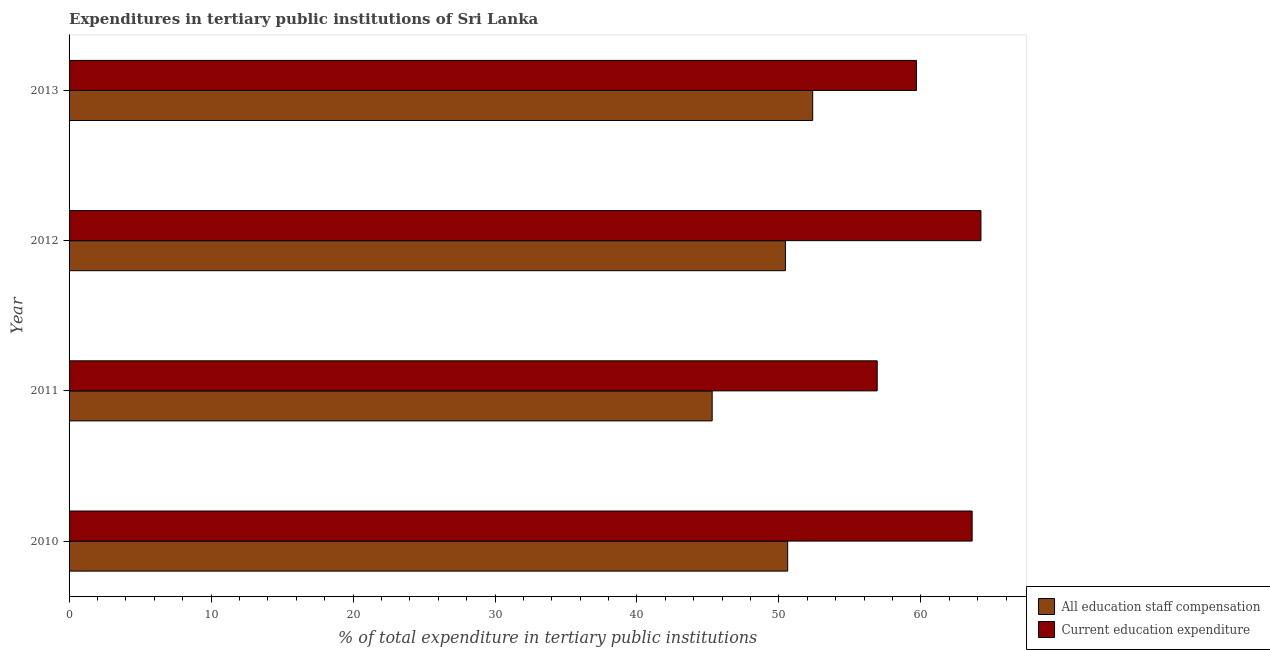Are the number of bars per tick equal to the number of legend labels?
Make the answer very short. Yes. What is the expenditure in staff compensation in 2013?
Keep it short and to the point. 52.38. Across all years, what is the maximum expenditure in education?
Offer a terse response. 64.23. Across all years, what is the minimum expenditure in education?
Offer a very short reply. 56.92. In which year was the expenditure in education maximum?
Offer a terse response. 2012. What is the total expenditure in education in the graph?
Your answer should be compact. 244.44. What is the difference between the expenditure in staff compensation in 2010 and that in 2011?
Give a very brief answer. 5.32. What is the difference between the expenditure in staff compensation in 2011 and the expenditure in education in 2012?
Make the answer very short. -18.93. What is the average expenditure in education per year?
Make the answer very short. 61.11. In the year 2013, what is the difference between the expenditure in education and expenditure in staff compensation?
Provide a succinct answer. 7.31. In how many years, is the expenditure in staff compensation greater than 32 %?
Your response must be concise. 4. What is the ratio of the expenditure in staff compensation in 2012 to that in 2013?
Your response must be concise. 0.96. Is the expenditure in education in 2011 less than that in 2012?
Your response must be concise. Yes. Is the difference between the expenditure in staff compensation in 2010 and 2011 greater than the difference between the expenditure in education in 2010 and 2011?
Your answer should be compact. No. What is the difference between the highest and the second highest expenditure in education?
Keep it short and to the point. 0.62. What is the difference between the highest and the lowest expenditure in education?
Provide a short and direct response. 7.31. Is the sum of the expenditure in education in 2010 and 2012 greater than the maximum expenditure in staff compensation across all years?
Your answer should be compact. Yes. What does the 1st bar from the top in 2010 represents?
Your answer should be compact. Current education expenditure. What does the 2nd bar from the bottom in 2010 represents?
Your answer should be very brief. Current education expenditure. How many years are there in the graph?
Offer a terse response. 4. What is the difference between two consecutive major ticks on the X-axis?
Provide a short and direct response. 10. Does the graph contain any zero values?
Your answer should be very brief. No. Does the graph contain grids?
Your response must be concise. No. Where does the legend appear in the graph?
Offer a terse response. Bottom right. How many legend labels are there?
Keep it short and to the point. 2. What is the title of the graph?
Your response must be concise. Expenditures in tertiary public institutions of Sri Lanka. Does "Age 15+" appear as one of the legend labels in the graph?
Your answer should be very brief. No. What is the label or title of the X-axis?
Keep it short and to the point. % of total expenditure in tertiary public institutions. What is the % of total expenditure in tertiary public institutions of All education staff compensation in 2010?
Give a very brief answer. 50.61. What is the % of total expenditure in tertiary public institutions in Current education expenditure in 2010?
Provide a short and direct response. 63.61. What is the % of total expenditure in tertiary public institutions in All education staff compensation in 2011?
Make the answer very short. 45.3. What is the % of total expenditure in tertiary public institutions in Current education expenditure in 2011?
Ensure brevity in your answer.  56.92. What is the % of total expenditure in tertiary public institutions in All education staff compensation in 2012?
Your answer should be very brief. 50.45. What is the % of total expenditure in tertiary public institutions of Current education expenditure in 2012?
Offer a terse response. 64.23. What is the % of total expenditure in tertiary public institutions in All education staff compensation in 2013?
Ensure brevity in your answer.  52.38. What is the % of total expenditure in tertiary public institutions in Current education expenditure in 2013?
Your answer should be very brief. 59.68. Across all years, what is the maximum % of total expenditure in tertiary public institutions of All education staff compensation?
Your answer should be very brief. 52.38. Across all years, what is the maximum % of total expenditure in tertiary public institutions of Current education expenditure?
Provide a succinct answer. 64.23. Across all years, what is the minimum % of total expenditure in tertiary public institutions in All education staff compensation?
Make the answer very short. 45.3. Across all years, what is the minimum % of total expenditure in tertiary public institutions in Current education expenditure?
Provide a short and direct response. 56.92. What is the total % of total expenditure in tertiary public institutions of All education staff compensation in the graph?
Keep it short and to the point. 198.74. What is the total % of total expenditure in tertiary public institutions in Current education expenditure in the graph?
Give a very brief answer. 244.44. What is the difference between the % of total expenditure in tertiary public institutions in All education staff compensation in 2010 and that in 2011?
Your response must be concise. 5.32. What is the difference between the % of total expenditure in tertiary public institutions of Current education expenditure in 2010 and that in 2011?
Make the answer very short. 6.69. What is the difference between the % of total expenditure in tertiary public institutions in All education staff compensation in 2010 and that in 2012?
Ensure brevity in your answer.  0.16. What is the difference between the % of total expenditure in tertiary public institutions in Current education expenditure in 2010 and that in 2012?
Make the answer very short. -0.62. What is the difference between the % of total expenditure in tertiary public institutions of All education staff compensation in 2010 and that in 2013?
Your response must be concise. -1.76. What is the difference between the % of total expenditure in tertiary public institutions of Current education expenditure in 2010 and that in 2013?
Offer a terse response. 3.92. What is the difference between the % of total expenditure in tertiary public institutions of All education staff compensation in 2011 and that in 2012?
Make the answer very short. -5.16. What is the difference between the % of total expenditure in tertiary public institutions of Current education expenditure in 2011 and that in 2012?
Offer a very short reply. -7.31. What is the difference between the % of total expenditure in tertiary public institutions in All education staff compensation in 2011 and that in 2013?
Your answer should be compact. -7.08. What is the difference between the % of total expenditure in tertiary public institutions in Current education expenditure in 2011 and that in 2013?
Offer a terse response. -2.76. What is the difference between the % of total expenditure in tertiary public institutions in All education staff compensation in 2012 and that in 2013?
Provide a short and direct response. -1.92. What is the difference between the % of total expenditure in tertiary public institutions in Current education expenditure in 2012 and that in 2013?
Offer a terse response. 4.54. What is the difference between the % of total expenditure in tertiary public institutions in All education staff compensation in 2010 and the % of total expenditure in tertiary public institutions in Current education expenditure in 2011?
Ensure brevity in your answer.  -6.31. What is the difference between the % of total expenditure in tertiary public institutions of All education staff compensation in 2010 and the % of total expenditure in tertiary public institutions of Current education expenditure in 2012?
Your answer should be very brief. -13.61. What is the difference between the % of total expenditure in tertiary public institutions in All education staff compensation in 2010 and the % of total expenditure in tertiary public institutions in Current education expenditure in 2013?
Offer a terse response. -9.07. What is the difference between the % of total expenditure in tertiary public institutions of All education staff compensation in 2011 and the % of total expenditure in tertiary public institutions of Current education expenditure in 2012?
Provide a short and direct response. -18.93. What is the difference between the % of total expenditure in tertiary public institutions of All education staff compensation in 2011 and the % of total expenditure in tertiary public institutions of Current education expenditure in 2013?
Offer a terse response. -14.39. What is the difference between the % of total expenditure in tertiary public institutions in All education staff compensation in 2012 and the % of total expenditure in tertiary public institutions in Current education expenditure in 2013?
Your response must be concise. -9.23. What is the average % of total expenditure in tertiary public institutions of All education staff compensation per year?
Provide a short and direct response. 49.69. What is the average % of total expenditure in tertiary public institutions of Current education expenditure per year?
Provide a short and direct response. 61.11. In the year 2010, what is the difference between the % of total expenditure in tertiary public institutions in All education staff compensation and % of total expenditure in tertiary public institutions in Current education expenditure?
Offer a terse response. -12.99. In the year 2011, what is the difference between the % of total expenditure in tertiary public institutions in All education staff compensation and % of total expenditure in tertiary public institutions in Current education expenditure?
Give a very brief answer. -11.62. In the year 2012, what is the difference between the % of total expenditure in tertiary public institutions in All education staff compensation and % of total expenditure in tertiary public institutions in Current education expenditure?
Your response must be concise. -13.77. In the year 2013, what is the difference between the % of total expenditure in tertiary public institutions of All education staff compensation and % of total expenditure in tertiary public institutions of Current education expenditure?
Ensure brevity in your answer.  -7.31. What is the ratio of the % of total expenditure in tertiary public institutions in All education staff compensation in 2010 to that in 2011?
Ensure brevity in your answer.  1.12. What is the ratio of the % of total expenditure in tertiary public institutions in Current education expenditure in 2010 to that in 2011?
Keep it short and to the point. 1.12. What is the ratio of the % of total expenditure in tertiary public institutions of All education staff compensation in 2010 to that in 2012?
Offer a terse response. 1. What is the ratio of the % of total expenditure in tertiary public institutions of All education staff compensation in 2010 to that in 2013?
Provide a short and direct response. 0.97. What is the ratio of the % of total expenditure in tertiary public institutions in Current education expenditure in 2010 to that in 2013?
Provide a succinct answer. 1.07. What is the ratio of the % of total expenditure in tertiary public institutions in All education staff compensation in 2011 to that in 2012?
Make the answer very short. 0.9. What is the ratio of the % of total expenditure in tertiary public institutions of Current education expenditure in 2011 to that in 2012?
Ensure brevity in your answer.  0.89. What is the ratio of the % of total expenditure in tertiary public institutions of All education staff compensation in 2011 to that in 2013?
Ensure brevity in your answer.  0.86. What is the ratio of the % of total expenditure in tertiary public institutions in Current education expenditure in 2011 to that in 2013?
Make the answer very short. 0.95. What is the ratio of the % of total expenditure in tertiary public institutions of All education staff compensation in 2012 to that in 2013?
Make the answer very short. 0.96. What is the ratio of the % of total expenditure in tertiary public institutions in Current education expenditure in 2012 to that in 2013?
Offer a terse response. 1.08. What is the difference between the highest and the second highest % of total expenditure in tertiary public institutions in All education staff compensation?
Your answer should be very brief. 1.76. What is the difference between the highest and the second highest % of total expenditure in tertiary public institutions of Current education expenditure?
Provide a short and direct response. 0.62. What is the difference between the highest and the lowest % of total expenditure in tertiary public institutions of All education staff compensation?
Offer a terse response. 7.08. What is the difference between the highest and the lowest % of total expenditure in tertiary public institutions in Current education expenditure?
Make the answer very short. 7.31. 